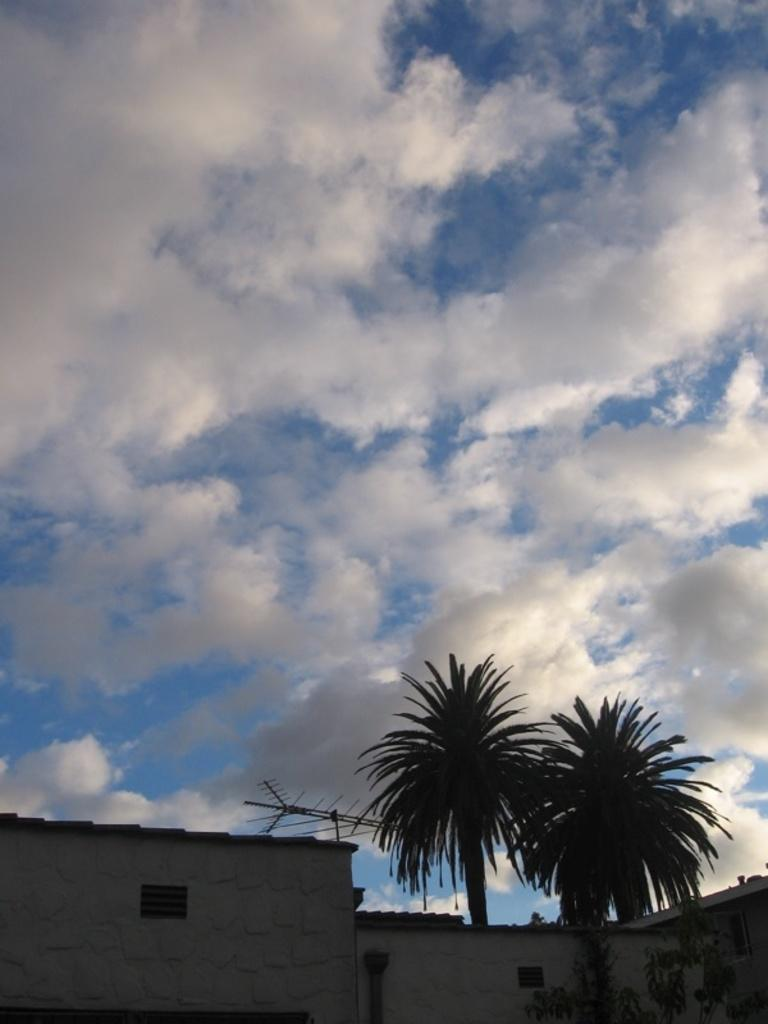What type of structures can be seen in the image? There are buildings in the image. What feature is present on the buildings in the image? There are windows in the image. What type of natural elements can be seen in the image? There are trees in the image. What part of the natural environment is visible in the image? The sky is visible in the image. What can be observed in the sky in the image? Clouds are present in the image. How would you describe the overall lighting in the image? The image appears to be slightly dark. Can you see a dock in the image? There is no dock present in the image. What type of chess piece is located on the roof of the building? There is no chess piece visible on any of the buildings in the image. 